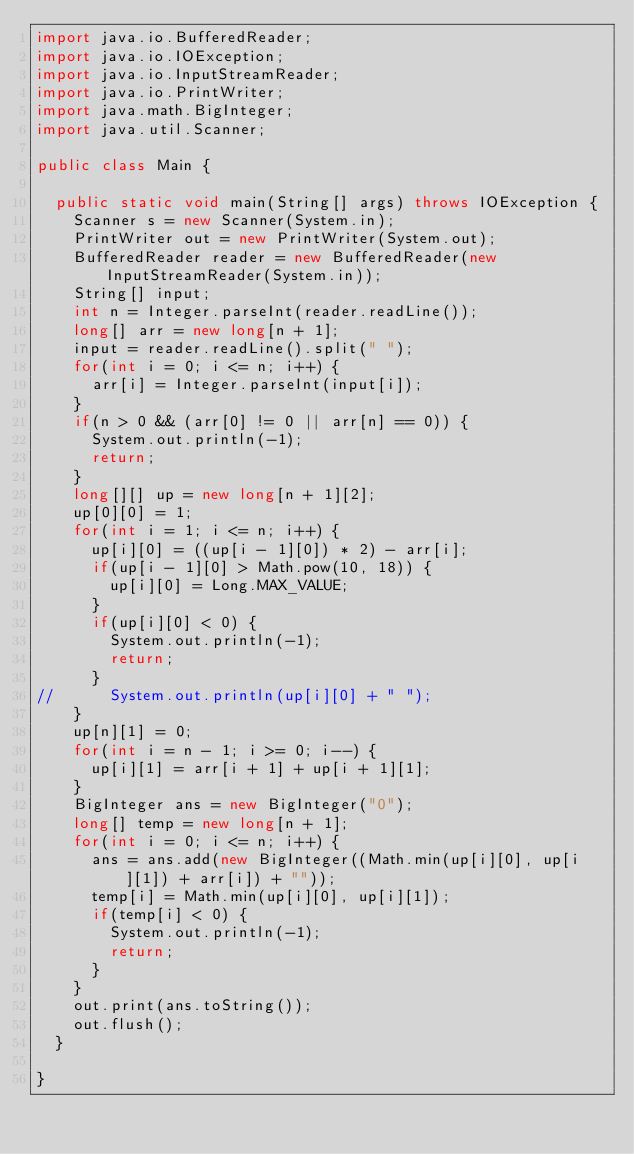Convert code to text. <code><loc_0><loc_0><loc_500><loc_500><_Java_>import java.io.BufferedReader;
import java.io.IOException;
import java.io.InputStreamReader;
import java.io.PrintWriter;
import java.math.BigInteger;
import java.util.Scanner;

public class Main {

	public static void main(String[] args) throws IOException {
		Scanner s = new Scanner(System.in);
		PrintWriter out = new PrintWriter(System.out);
		BufferedReader reader = new BufferedReader(new InputStreamReader(System.in));
		String[] input;
		int n = Integer.parseInt(reader.readLine());
		long[] arr = new long[n + 1];
		input = reader.readLine().split(" ");
		for(int i = 0; i <= n; i++) {
			arr[i] = Integer.parseInt(input[i]);
		}
		if(n > 0 && (arr[0] != 0 || arr[n] == 0)) {
			System.out.println(-1);
			return;
		}
		long[][] up = new long[n + 1][2];
		up[0][0] = 1;
		for(int i = 1; i <= n; i++) {
			up[i][0] = ((up[i - 1][0]) * 2) - arr[i];
			if(up[i - 1][0] > Math.pow(10, 18)) {
				up[i][0] = Long.MAX_VALUE;
			}
			if(up[i][0] < 0) {
				System.out.println(-1);
				return;
			}
//			System.out.println(up[i][0] + " ");
		}
		up[n][1] = 0;
		for(int i = n - 1; i >= 0; i--) {
			up[i][1] = arr[i + 1] + up[i + 1][1];
		}
		BigInteger ans = new BigInteger("0");
		long[] temp = new long[n + 1];
		for(int i = 0; i <= n; i++) {
			ans = ans.add(new BigInteger((Math.min(up[i][0], up[i][1]) + arr[i]) + ""));
			temp[i] = Math.min(up[i][0], up[i][1]);
			if(temp[i] < 0) {
				System.out.println(-1);
				return;
			}
		}
		out.print(ans.toString());
		out.flush();
	}

}
</code> 